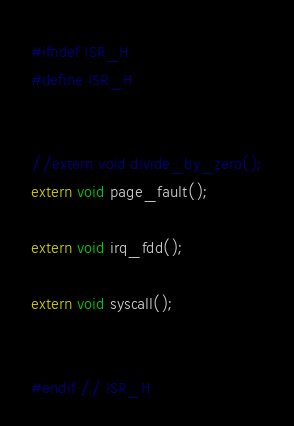Convert code to text. <code><loc_0><loc_0><loc_500><loc_500><_C_>#ifndef ISR_H
#define ISR_H


//extern void divide_by_zero();
extern void page_fault();

extern void irq_fdd();

extern void syscall();


#endif // ISR_H
</code> 